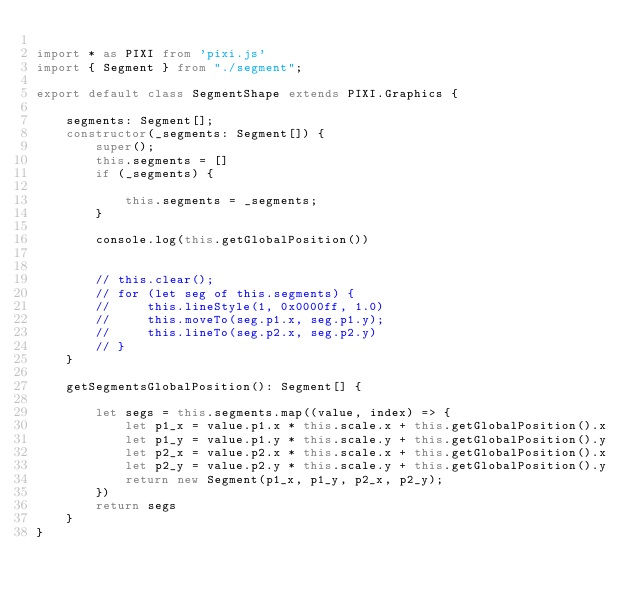Convert code to text. <code><loc_0><loc_0><loc_500><loc_500><_TypeScript_>
import * as PIXI from 'pixi.js'
import { Segment } from "./segment";

export default class SegmentShape extends PIXI.Graphics {

    segments: Segment[];
    constructor(_segments: Segment[]) {
        super();
        this.segments = []
        if (_segments) {

            this.segments = _segments;
        }

        console.log(this.getGlobalPosition())


        // this.clear();
        // for (let seg of this.segments) {
        //     this.lineStyle(1, 0x0000ff, 1.0)
        //     this.moveTo(seg.p1.x, seg.p1.y);
        //     this.lineTo(seg.p2.x, seg.p2.y)
        // }
    }

    getSegmentsGlobalPosition(): Segment[] {

        let segs = this.segments.map((value, index) => {
            let p1_x = value.p1.x * this.scale.x + this.getGlobalPosition().x
            let p1_y = value.p1.y * this.scale.y + this.getGlobalPosition().y
            let p2_x = value.p2.x * this.scale.x + this.getGlobalPosition().x
            let p2_y = value.p2.y * this.scale.y + this.getGlobalPosition().y
            return new Segment(p1_x, p1_y, p2_x, p2_y);
        })
        return segs
    }
}</code> 